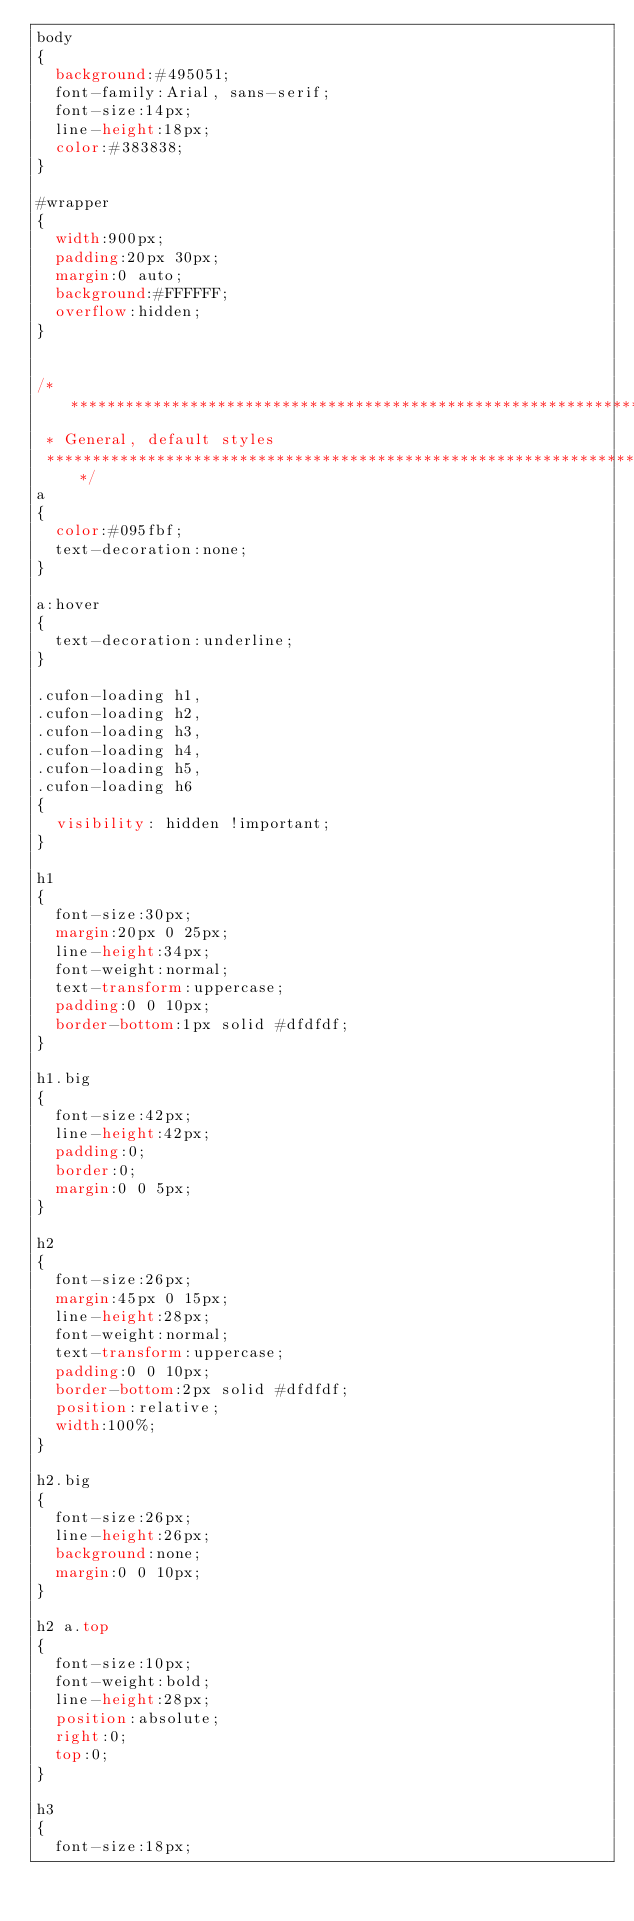<code> <loc_0><loc_0><loc_500><loc_500><_CSS_>body
{
  background:#495051;
  font-family:Arial, sans-serif;
  font-size:14px;
  line-height:18px;
  color:#383838;
}

#wrapper
{
  width:900px;
  padding:20px 30px;
  margin:0 auto;
  background:#FFFFFF;
  overflow:hidden;
}


/*********************************************************************
 * General, default styles
 *********************************************************************/
a
{
  color:#095fbf;
  text-decoration:none;
}

a:hover
{
  text-decoration:underline;
}

.cufon-loading h1,
.cufon-loading h2,
.cufon-loading h3,
.cufon-loading h4,
.cufon-loading h5,
.cufon-loading h6
{
	visibility: hidden !important;
}

h1
{
  font-size:30px;
  margin:20px 0 25px;
  line-height:34px;
  font-weight:normal;
  text-transform:uppercase;
  padding:0 0 10px;
  border-bottom:1px solid #dfdfdf;
}

h1.big
{
  font-size:42px;
  line-height:42px;
  padding:0;
  border:0;
  margin:0 0 5px;
}

h2
{
  font-size:26px;
  margin:45px 0 15px;
  line-height:28px;
  font-weight:normal;
  text-transform:uppercase;
  padding:0 0 10px;
  border-bottom:2px solid #dfdfdf;
  position:relative;
  width:100%;
}

h2.big
{
  font-size:26px;
  line-height:26px;
  background:none;
  margin:0 0 10px;
}

h2 a.top
{
  font-size:10px;
  font-weight:bold;
  line-height:28px;
  position:absolute;
  right:0;
  top:0;
}

h3
{
  font-size:18px;</code> 